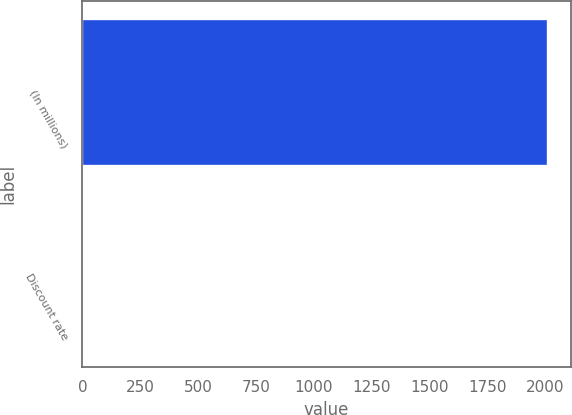Convert chart. <chart><loc_0><loc_0><loc_500><loc_500><bar_chart><fcel>(In millions)<fcel>Discount rate<nl><fcel>2010<fcel>5.5<nl></chart> 